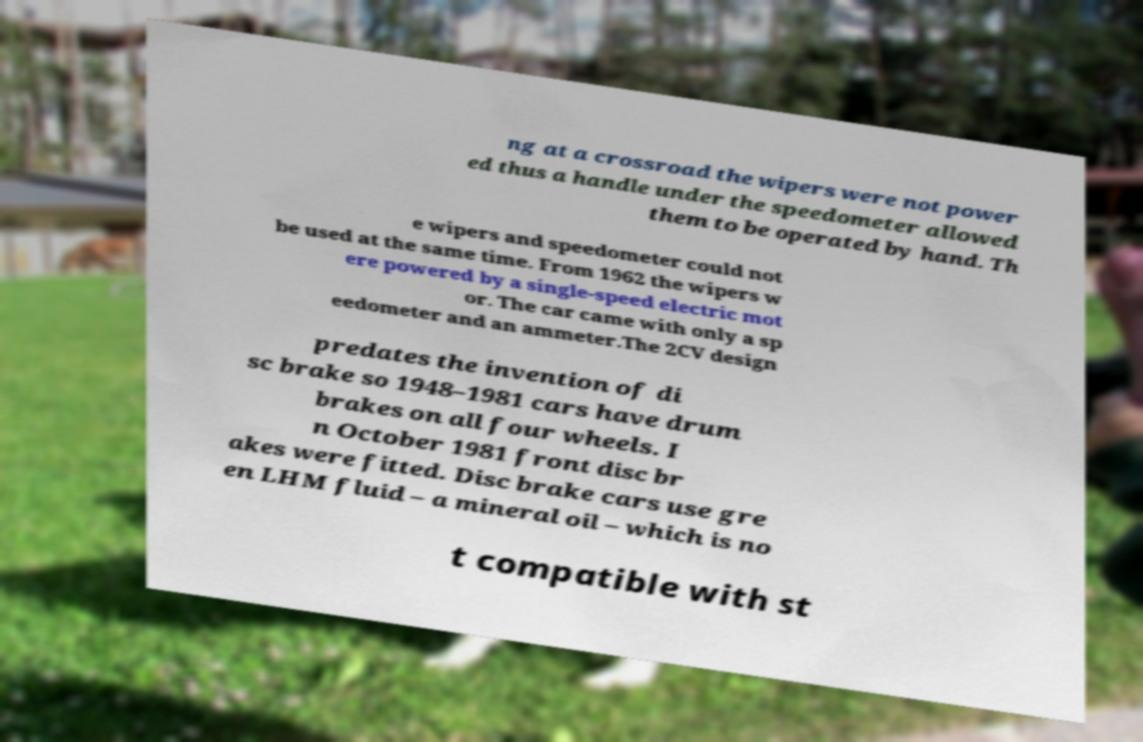Could you assist in decoding the text presented in this image and type it out clearly? ng at a crossroad the wipers were not power ed thus a handle under the speedometer allowed them to be operated by hand. Th e wipers and speedometer could not be used at the same time. From 1962 the wipers w ere powered by a single-speed electric mot or. The car came with only a sp eedometer and an ammeter.The 2CV design predates the invention of di sc brake so 1948–1981 cars have drum brakes on all four wheels. I n October 1981 front disc br akes were fitted. Disc brake cars use gre en LHM fluid – a mineral oil – which is no t compatible with st 